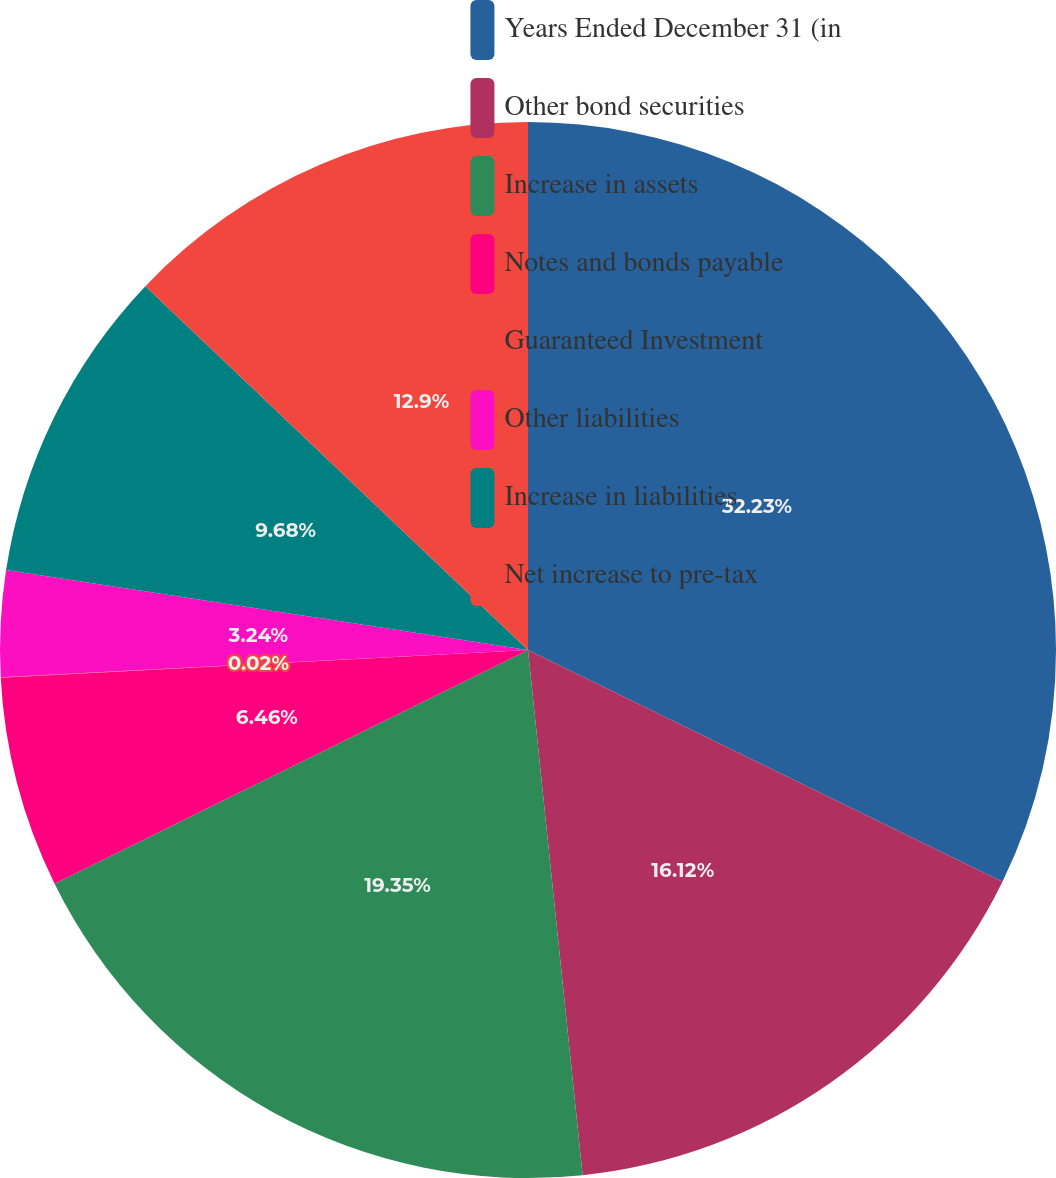<chart> <loc_0><loc_0><loc_500><loc_500><pie_chart><fcel>Years Ended December 31 (in<fcel>Other bond securities<fcel>Increase in assets<fcel>Notes and bonds payable<fcel>Guaranteed Investment<fcel>Other liabilities<fcel>Increase in liabilities<fcel>Net increase to pre-tax<nl><fcel>32.23%<fcel>16.12%<fcel>19.35%<fcel>6.46%<fcel>0.02%<fcel>3.24%<fcel>9.68%<fcel>12.9%<nl></chart> 